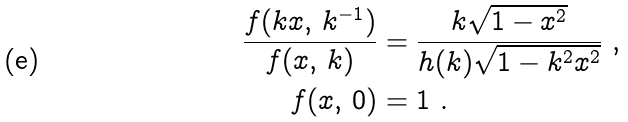Convert formula to latex. <formula><loc_0><loc_0><loc_500><loc_500>\frac { f ( k x , \, k ^ { - 1 } ) } { f ( x , \, k ) } & = \frac { k \sqrt { 1 - x ^ { 2 } } } { h ( k ) \sqrt { 1 - k ^ { 2 } x ^ { 2 } } } \ , \\ f ( x , \, 0 ) & = 1 \ .</formula> 